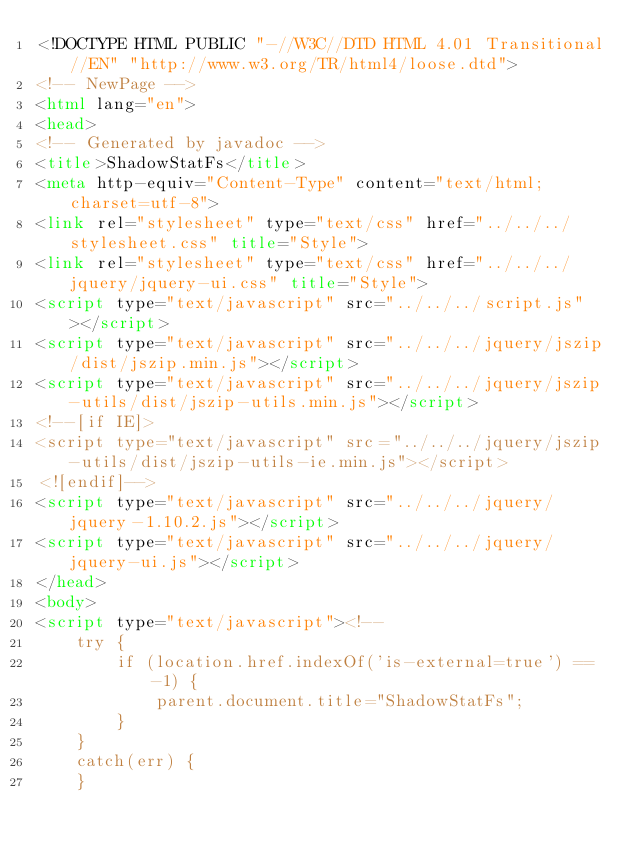Convert code to text. <code><loc_0><loc_0><loc_500><loc_500><_HTML_><!DOCTYPE HTML PUBLIC "-//W3C//DTD HTML 4.01 Transitional//EN" "http://www.w3.org/TR/html4/loose.dtd">
<!-- NewPage -->
<html lang="en">
<head>
<!-- Generated by javadoc -->
<title>ShadowStatFs</title>
<meta http-equiv="Content-Type" content="text/html; charset=utf-8">
<link rel="stylesheet" type="text/css" href="../../../stylesheet.css" title="Style">
<link rel="stylesheet" type="text/css" href="../../../jquery/jquery-ui.css" title="Style">
<script type="text/javascript" src="../../../script.js"></script>
<script type="text/javascript" src="../../../jquery/jszip/dist/jszip.min.js"></script>
<script type="text/javascript" src="../../../jquery/jszip-utils/dist/jszip-utils.min.js"></script>
<!--[if IE]>
<script type="text/javascript" src="../../../jquery/jszip-utils/dist/jszip-utils-ie.min.js"></script>
<![endif]-->
<script type="text/javascript" src="../../../jquery/jquery-1.10.2.js"></script>
<script type="text/javascript" src="../../../jquery/jquery-ui.js"></script>
</head>
<body>
<script type="text/javascript"><!--
    try {
        if (location.href.indexOf('is-external=true') == -1) {
            parent.document.title="ShadowStatFs";
        }
    }
    catch(err) {
    }</code> 